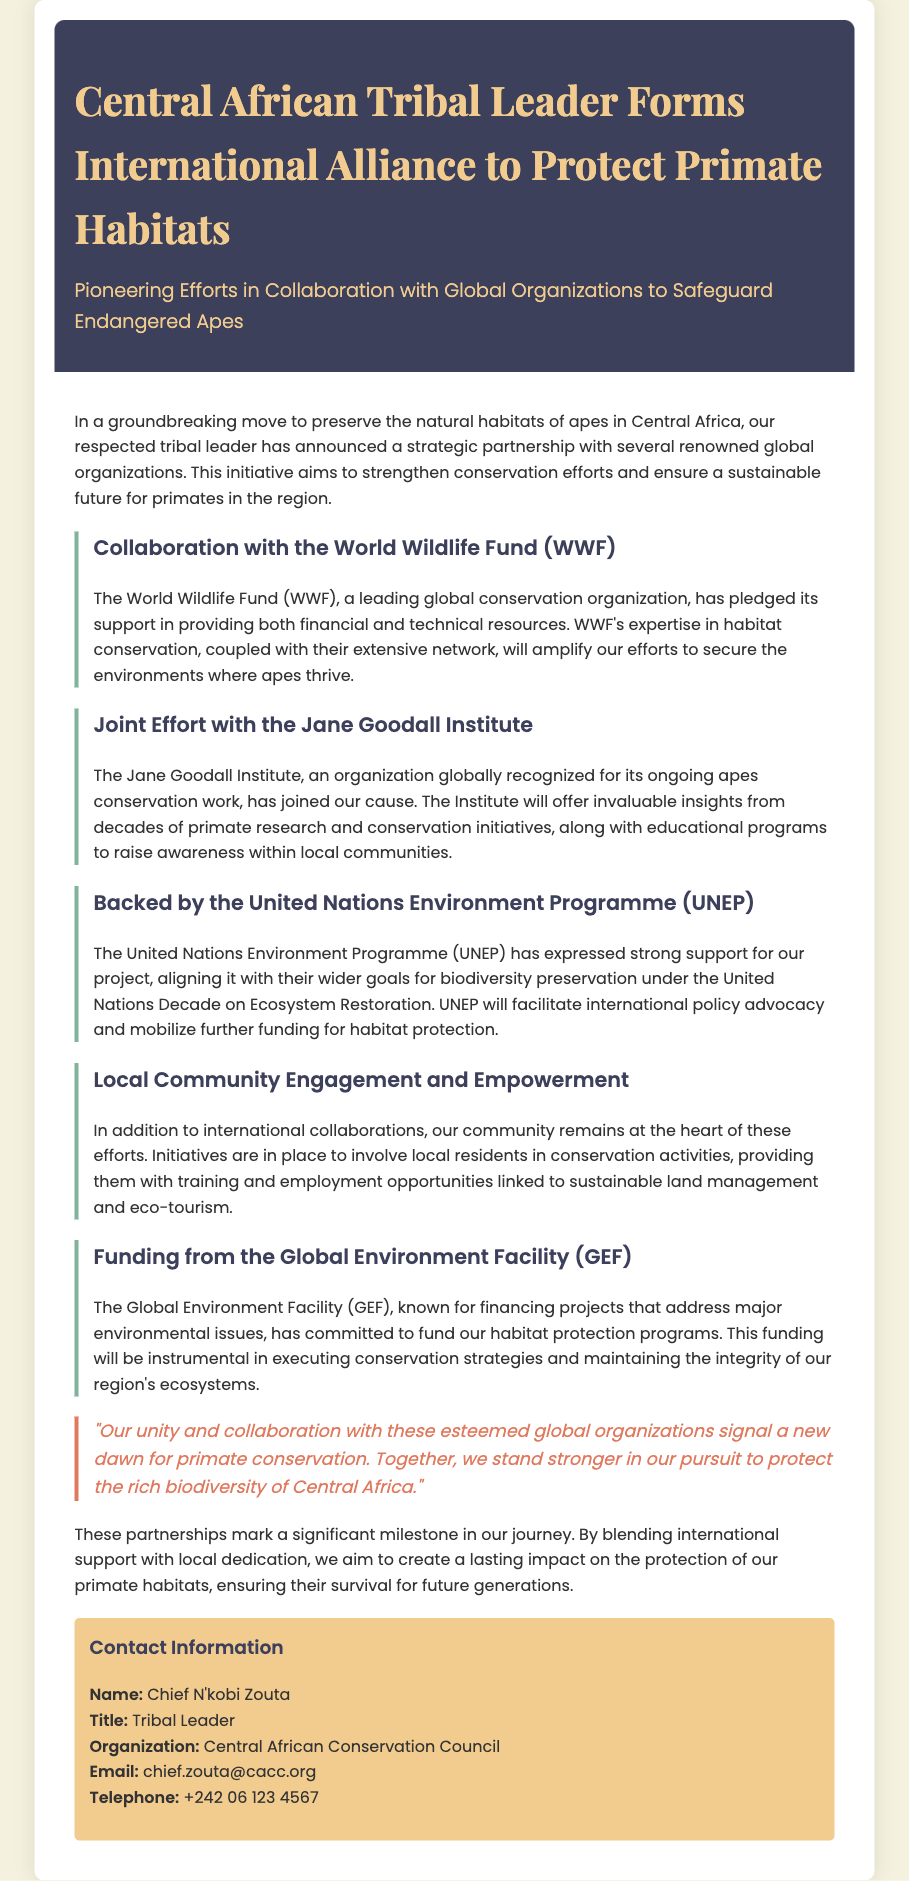what is the title of the press release? The title of the press release is indicated prominently at the top of the document.
Answer: Central African Tribal Leader Forms International Alliance to Protect Primate Habitats who is the tribal leader mentioned in the document? The document specifies the tribal leader's name in the contact information section.
Answer: Chief N'kobi Zouta which organization has pledged financial and technical support? The document identifies the organization providing support in the first collaboration section.
Answer: World Wildlife Fund (WWF) what is the goal of the partnership with the Jane Goodall Institute? This goal is outlined in the section detailing the collaboration with the Jane Goodall Institute.
Answer: Provide invaluable insights from decades of primate research how is the United Nations Environment Programme (UNEP) supporting the project? The manner of support is described in the section regarding UNEP’s involvement.
Answer: Facilitate international policy advocacy what kind of empowerment initiatives are mentioned for local communities? The initiatives aimed at local community empowerment are detailed in their respective section.
Answer: Conservation activities, training, and employment opportunities what is the funding organization mentioned for habitat protection programs? The specific funding organization is mentioned in a dedicated section about funding.
Answer: Global Environment Facility (GEF) what is indicated as a significant milestone in the document? The document highlights a particular outcome regarded as a milestone toward conservation.
Answer: Partnerships mark a significant milestone in our journey how does the document conclude regarding the unity of the efforts? The concluding thoughts summarize the importance of collaborative efforts in conservation.
Answer: A new dawn for primate conservation 